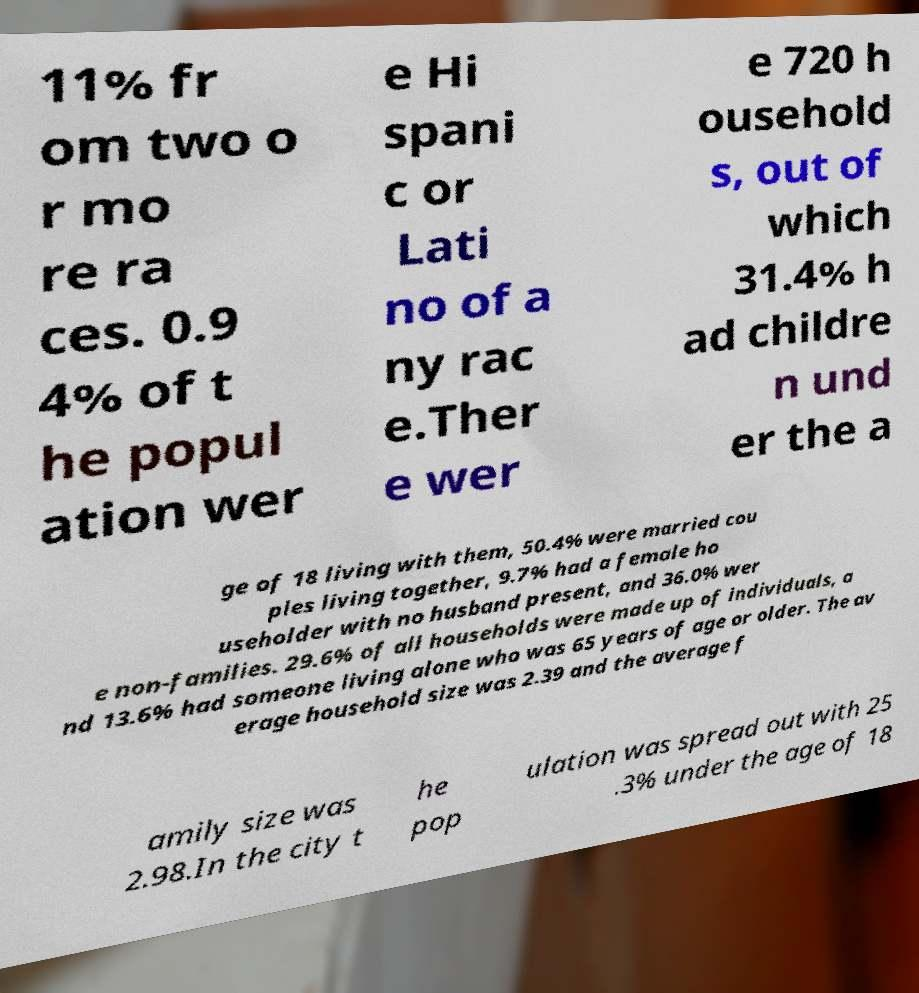Could you extract and type out the text from this image? 11% fr om two o r mo re ra ces. 0.9 4% of t he popul ation wer e Hi spani c or Lati no of a ny rac e.Ther e wer e 720 h ousehold s, out of which 31.4% h ad childre n und er the a ge of 18 living with them, 50.4% were married cou ples living together, 9.7% had a female ho useholder with no husband present, and 36.0% wer e non-families. 29.6% of all households were made up of individuals, a nd 13.6% had someone living alone who was 65 years of age or older. The av erage household size was 2.39 and the average f amily size was 2.98.In the city t he pop ulation was spread out with 25 .3% under the age of 18 